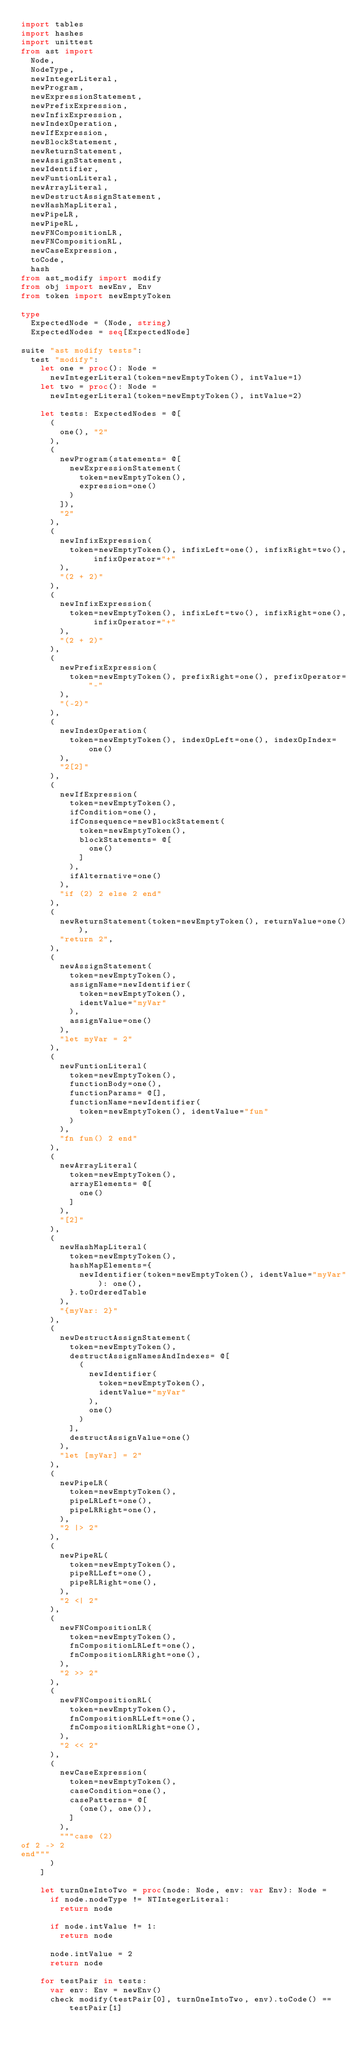Convert code to text. <code><loc_0><loc_0><loc_500><loc_500><_Nim_>import tables
import hashes
import unittest
from ast import
  Node,
  NodeType,
  newIntegerLiteral,
  newProgram,
  newExpressionStatement,
  newPrefixExpression,
  newInfixExpression,
  newIndexOperation,
  newIfExpression,
  newBlockStatement,
  newReturnStatement,
  newAssignStatement,
  newIdentifier,
  newFuntionLiteral,
  newArrayLiteral,
  newDestructAssignStatement,
  newHashMapLiteral,
  newPipeLR,
  newPipeRL,
  newFNCompositionLR,
  newFNCompositionRL,
  newCaseExpression,
  toCode,
  hash
from ast_modify import modify
from obj import newEnv, Env
from token import newEmptyToken

type
  ExpectedNode = (Node, string)
  ExpectedNodes = seq[ExpectedNode]

suite "ast modify tests":
  test "modify":
    let one = proc(): Node =
      newIntegerLiteral(token=newEmptyToken(), intValue=1)
    let two = proc(): Node =
      newIntegerLiteral(token=newEmptyToken(), intValue=2)

    let tests: ExpectedNodes = @[
      (
        one(), "2"
      ),
      (
        newProgram(statements= @[
          newExpressionStatement(
            token=newEmptyToken(),
            expression=one()
          )
        ]),
        "2"
      ),
      (
        newInfixExpression(
          token=newEmptyToken(), infixLeft=one(), infixRight=two(), infixOperator="+"
        ),
        "(2 + 2)"
      ),
      (
        newInfixExpression(
          token=newEmptyToken(), infixLeft=two(), infixRight=one(), infixOperator="+"
        ),
        "(2 + 2)"
      ),
      (
        newPrefixExpression(
          token=newEmptyToken(), prefixRight=one(), prefixOperator="-"
        ),
        "(-2)"
      ),
      (
        newIndexOperation(
          token=newEmptyToken(), indexOpLeft=one(), indexOpIndex=one()
        ),
        "2[2]"
      ),
      (
        newIfExpression(
          token=newEmptyToken(),
          ifCondition=one(),
          ifConsequence=newBlockStatement(
            token=newEmptyToken(),
            blockStatements= @[
              one()
            ]
          ),
          ifAlternative=one()
        ),
        "if (2) 2 else 2 end"
      ),
      (
        newReturnStatement(token=newEmptyToken(), returnValue=one()),
        "return 2",
      ),
      (
        newAssignStatement(
          token=newEmptyToken(),
          assignName=newIdentifier(
            token=newEmptyToken(),
            identValue="myVar"
          ),
          assignValue=one()
        ),
        "let myVar = 2"
      ),
      (
        newFuntionLiteral(
          token=newEmptyToken(),
          functionBody=one(),
          functionParams= @[],
          functionName=newIdentifier(
            token=newEmptyToken(), identValue="fun"
          )
        ),
        "fn fun() 2 end"
      ),
      (
        newArrayLiteral(
          token=newEmptyToken(),
          arrayElements= @[
            one()
          ]
        ),
        "[2]"
      ),
      (
        newHashMapLiteral(
          token=newEmptyToken(),
          hashMapElements={
            newIdentifier(token=newEmptyToken(), identValue="myVar"): one(),
          }.toOrderedTable
        ),
        "{myVar: 2}"
      ),
      (
        newDestructAssignStatement(
          token=newEmptyToken(),
          destructAssignNamesAndIndexes= @[
            (
              newIdentifier(
                token=newEmptyToken(),
                identValue="myVar"
              ),
              one()
            )
          ],
          destructAssignValue=one()
        ),
        "let [myVar] = 2"
      ),
      (
        newPipeLR(
          token=newEmptyToken(),
          pipeLRLeft=one(),
          pipeLRRight=one(),
        ),
        "2 |> 2"
      ),
      (
        newPipeRL(
          token=newEmptyToken(),
          pipeRLLeft=one(),
          pipeRLRight=one(),
        ),
        "2 <| 2"
      ),
      (
        newFNCompositionLR(
          token=newEmptyToken(),
          fnCompositionLRLeft=one(),
          fnCompositionLRRight=one(),
        ),
        "2 >> 2"
      ),
      (
        newFNCompositionRL(
          token=newEmptyToken(),
          fnCompositionRLLeft=one(),
          fnCompositionRLRight=one(),
        ),
        "2 << 2"
      ),
      (
        newCaseExpression(
          token=newEmptyToken(),
          caseCondition=one(),
          casePatterns= @[
            (one(), one()),
          ]
        ),
        """case (2)
of 2 -> 2
end"""
      )
    ]

    let turnOneIntoTwo = proc(node: Node, env: var Env): Node =
      if node.nodeType != NTIntegerLiteral:
        return node

      if node.intValue != 1:
        return node

      node.intValue = 2
      return node

    for testPair in tests:
      var env: Env = newEnv()
      check modify(testPair[0], turnOneIntoTwo, env).toCode() == testPair[1]
</code> 